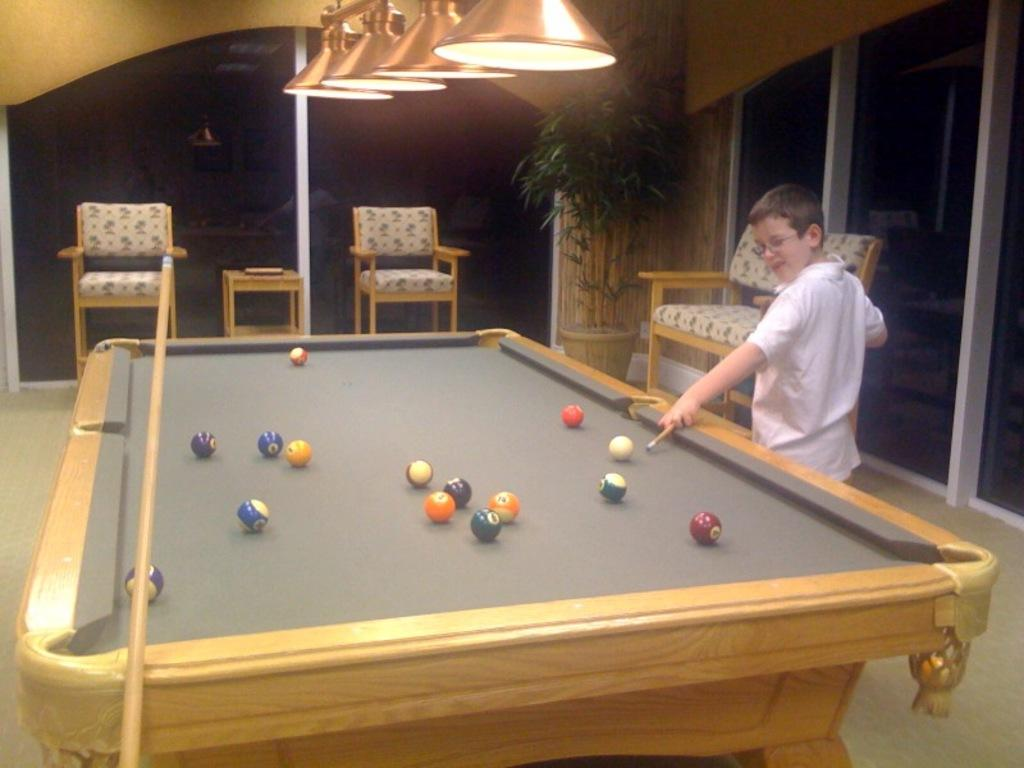What is the main subject of the image? The main subject of the image is a kid. What is the kid wearing? The kid is wearing a white shirt. What is the kid holding in the image? The kid is holding a snooker stick. What is in front of the kid? There is a snooker table in front of the kid. What can be seen in the background of the image? There are three chairs in the background of the image. What magic trick is the kid performing with the snooker stick in the image? There is no indication of a magic trick being performed in the image; the kid is simply holding a snooker stick. What title does the kid hold in the image? There is no title mentioned or depicted in the image. 